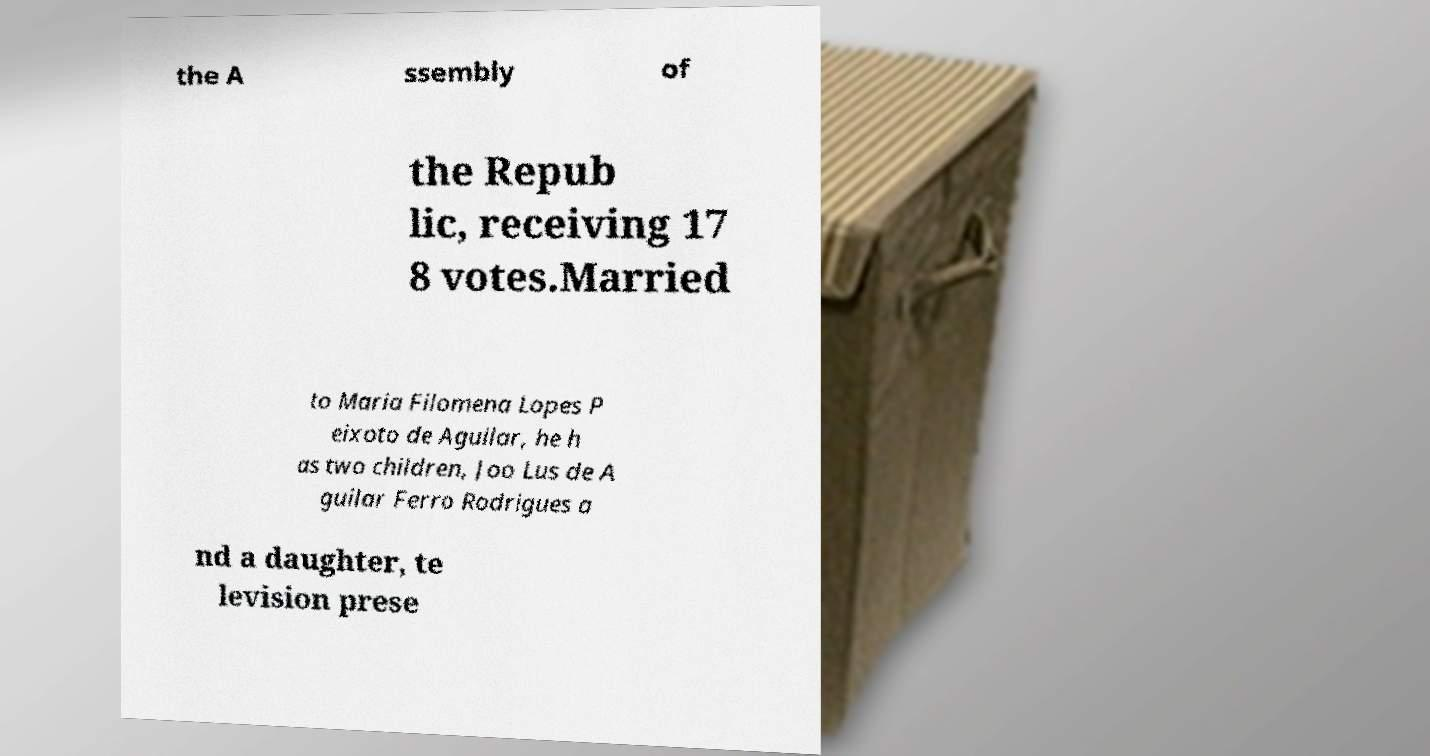Please identify and transcribe the text found in this image. the A ssembly of the Repub lic, receiving 17 8 votes.Married to Maria Filomena Lopes P eixoto de Aguilar, he h as two children, Joo Lus de A guilar Ferro Rodrigues a nd a daughter, te levision prese 